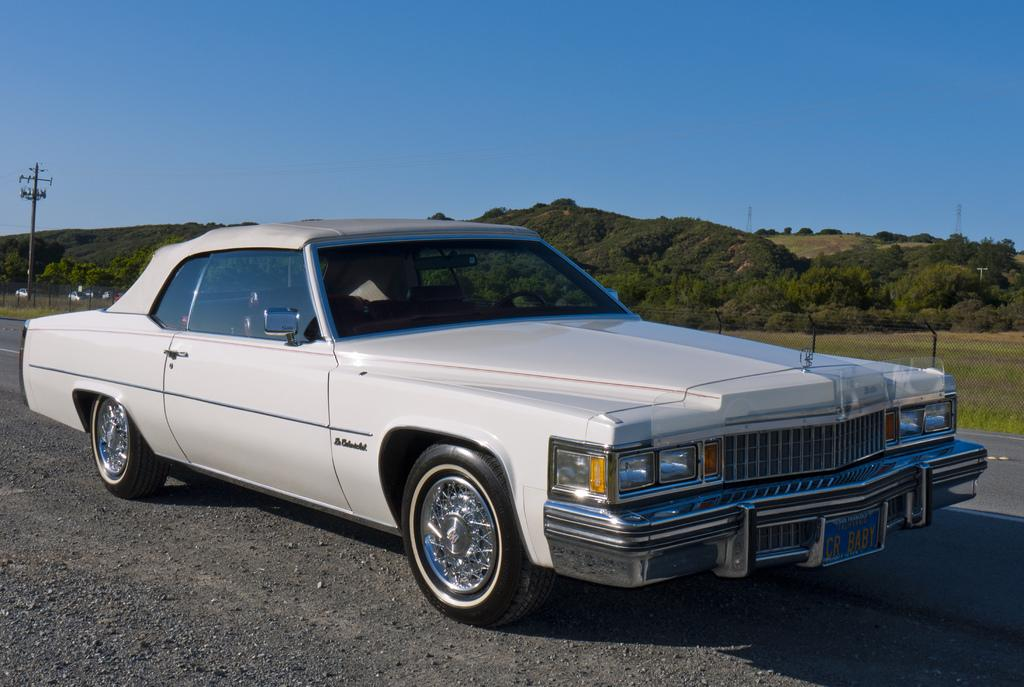What is the main subject of the image? There is a car on the road in the image. What is located behind the car? There is a pole behind the car. What is situated behind the pole? There are plants behind the pole. How would you describe the color of the sky in the image? The sky is blue in the image. Can you tell me how many times the car exchanges fog with the plants in the image? There is no fog present in the image, and therefore no exchange can be observed between the car and the plants. 